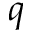<formula> <loc_0><loc_0><loc_500><loc_500>q</formula> 